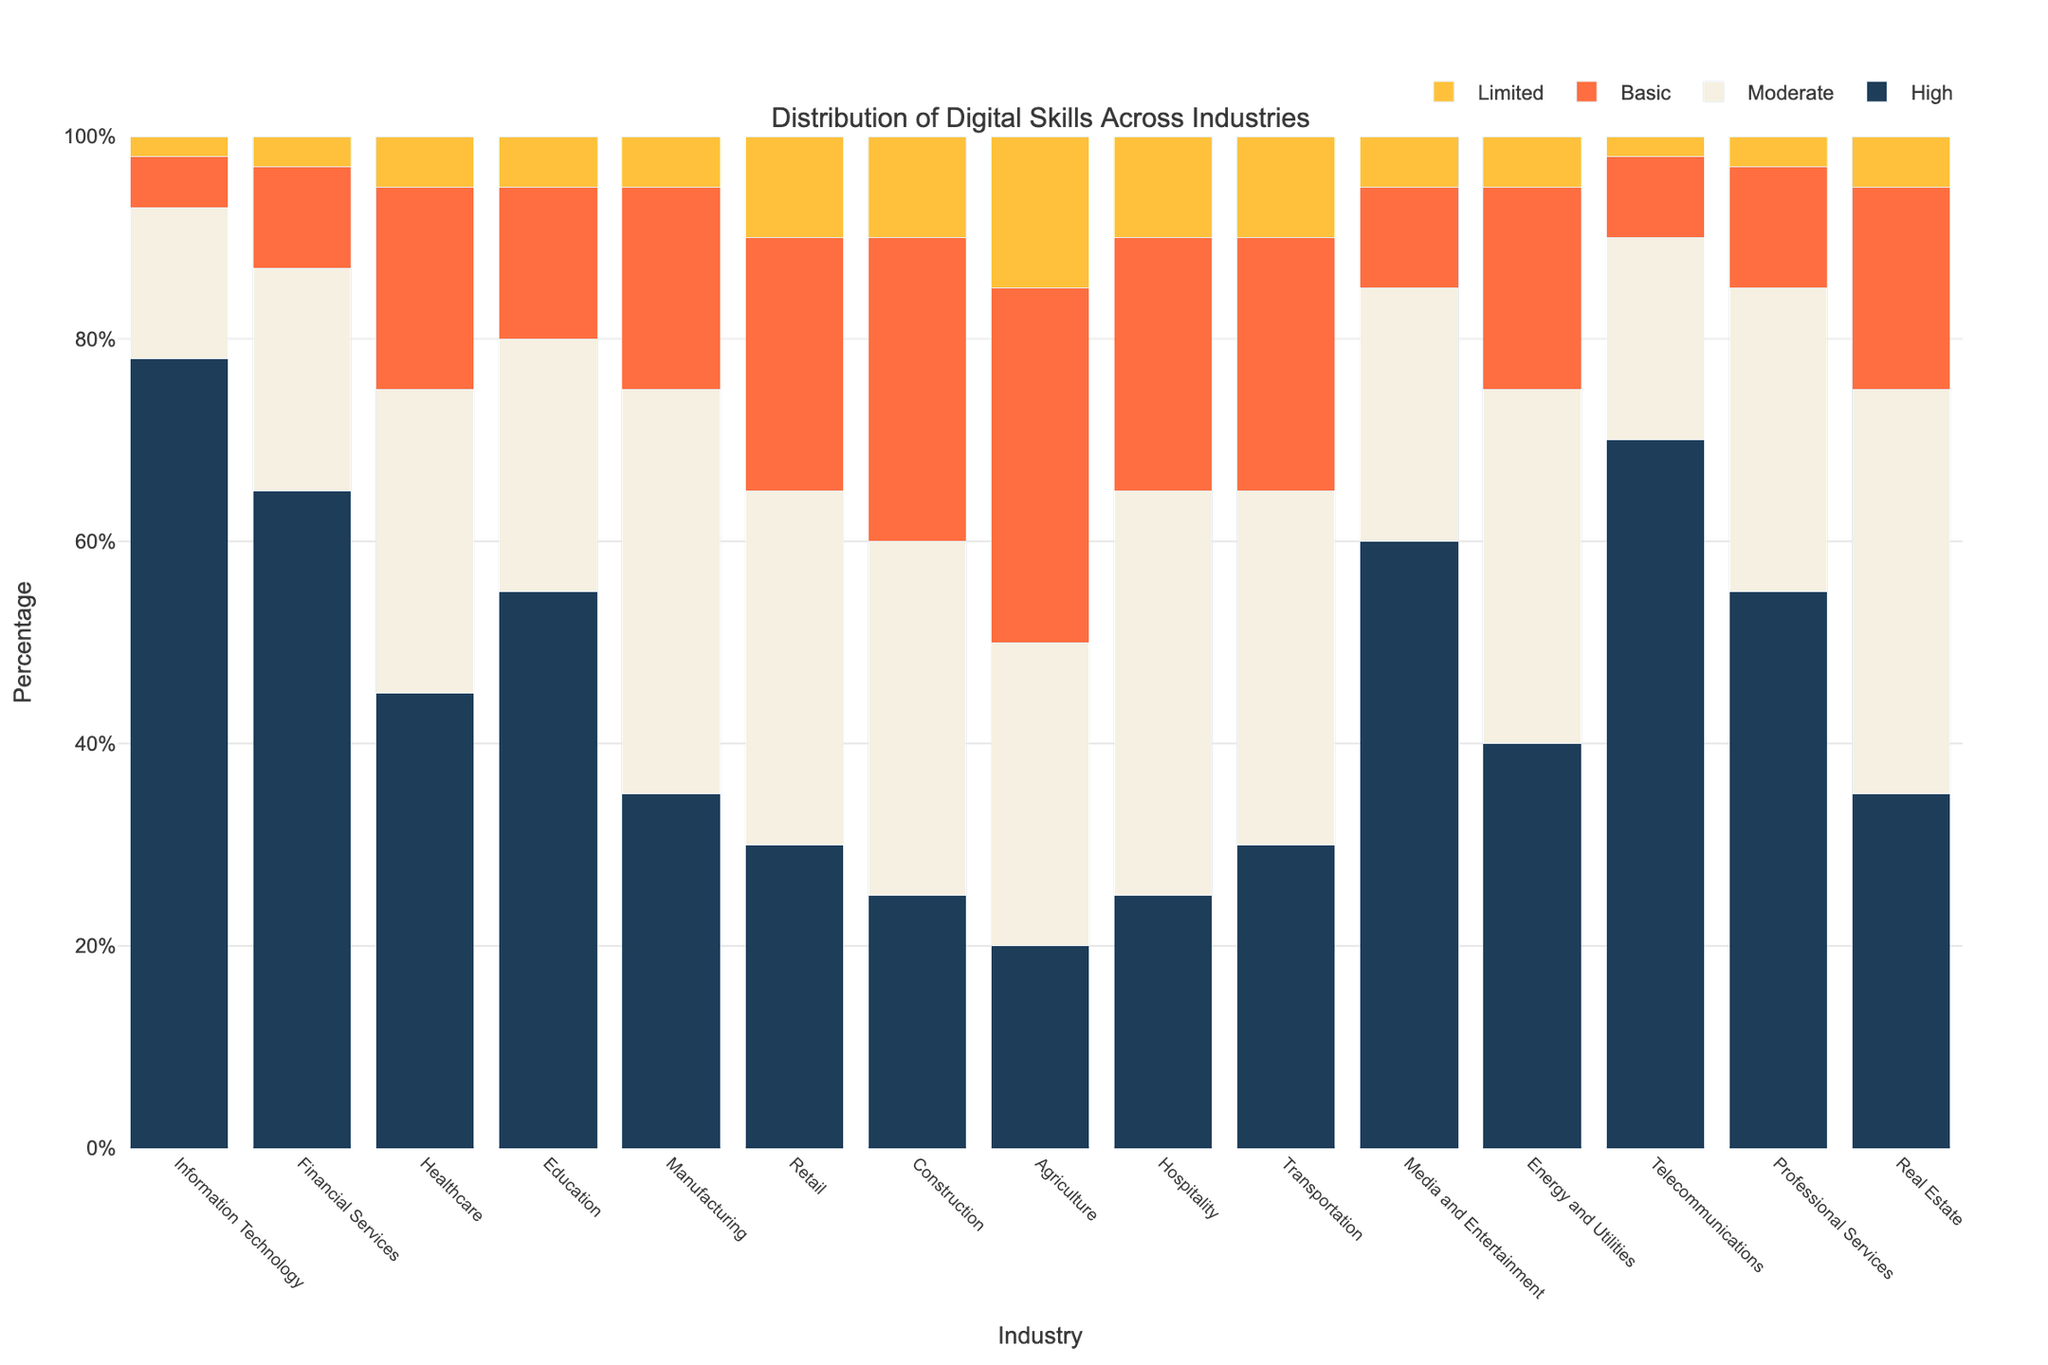What's the percentage of high digital skills in the Information Technology industry? Look at the bar labeled "Information Technology" for the "High" digital skills category. The height of the bar corresponds to the percentage, which is 78%.
Answer: 78% Which industry has the highest percentage of limited digital skills? Compare the bars in the "Limited Digital Skills" category across all industries. The highest bar belongs to Agriculture with 15%.
Answer: Agriculture What is the difference between the percentage of high digital skills in Telecommunications and Healthcare? Find the height of the "High" digital skills bar for both Telecommunications (70%) and Healthcare (45%). Subtract the percentage of Healthcare from Telecommunications: 70% - 45% = 25%.
Answer: 25% In which industry is the percentage of moderate digital skills closest to 35%? Look at the "Moderate" digital skills bars and identify those close to 35%. Both Construction and Transportation have bars at exactly 35%.
Answer: Construction and Transportation What is the average percentage of high digital skills across the Finance, Education, and Healthcare industries? Find the percentages for high digital skills in Finance (65%), Education (55%), and Healthcare (45%). Calculate the average: (65 + 55 + 45) / 3 = 165 / 3 = 55%.
Answer: 55% How does the percentage of basic digital skills in Retail compare to Tourism? Compare the "Basic" digital skills percentage for Retail (25%) and Hospitality (25%). Both are equal at 25%.
Answer: Equal at 25% Which industry has a significantly lower percentage of high digital skills compared to others? Identify industries with low percentages in the "High" digital skills category. Manufacturing (35%), Retail (30%), Construction (25%), Agriculture (20%), and Hospitality (25%) are among the lowest compared to most other industries.
Answer: Agriculture Is the percentage of moderate digital skills higher in Manufacturing or Media and Entertainment? Compare the "Moderate" digital skills bars for Manufacturing (40%) and Media and Entertainment (25%). Manufacturing has a higher percentage of 40%.
Answer: Manufacturing Looking at the Education industry, what is the combined percentage of high and moderate digital skills? Find the percentages of high digital skills (55%) and moderate digital skills (25%) for Education and sum them: 55% + 25% = 80%.
Answer: 80% In which industry does the percentage of high digital skills exceed 50% but less than 60%? Identify industries with "High" digital skills percentages in this range. Media and Entertainment have a high digital skills percentage of 60%, which is slightly above 50% but closest to the given range.
Answer: Media and Entertainment 